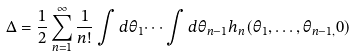<formula> <loc_0><loc_0><loc_500><loc_500>\Delta = \frac { 1 } { 2 } \sum _ { n = 1 } ^ { \infty } \frac { 1 } { n ! } \int d \theta _ { 1 } \dots \int d \theta _ { n - 1 } h _ { n } ( \theta _ { 1 } , \dots , \theta _ { n - 1 , } 0 )</formula> 